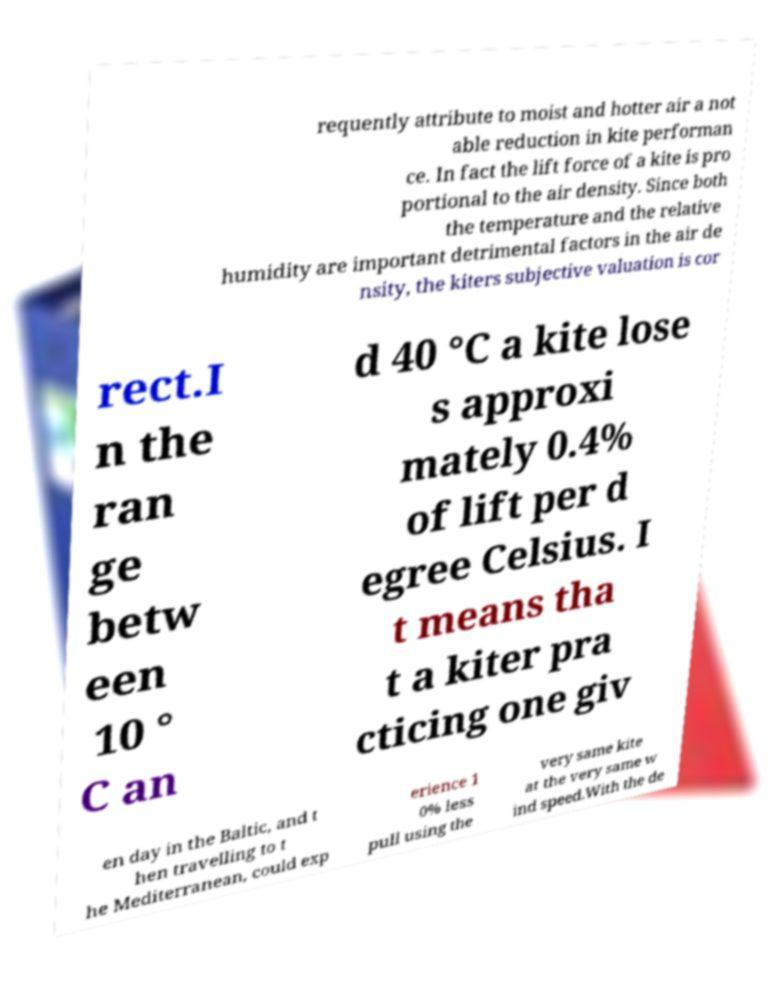Could you assist in decoding the text presented in this image and type it out clearly? requently attribute to moist and hotter air a not able reduction in kite performan ce. In fact the lift force of a kite is pro portional to the air density. Since both the temperature and the relative humidity are important detrimental factors in the air de nsity, the kiters subjective valuation is cor rect.I n the ran ge betw een 10 ° C an d 40 °C a kite lose s approxi mately 0.4% of lift per d egree Celsius. I t means tha t a kiter pra cticing one giv en day in the Baltic, and t hen travelling to t he Mediterranean, could exp erience 1 0% less pull using the very same kite at the very same w ind speed.With the de 